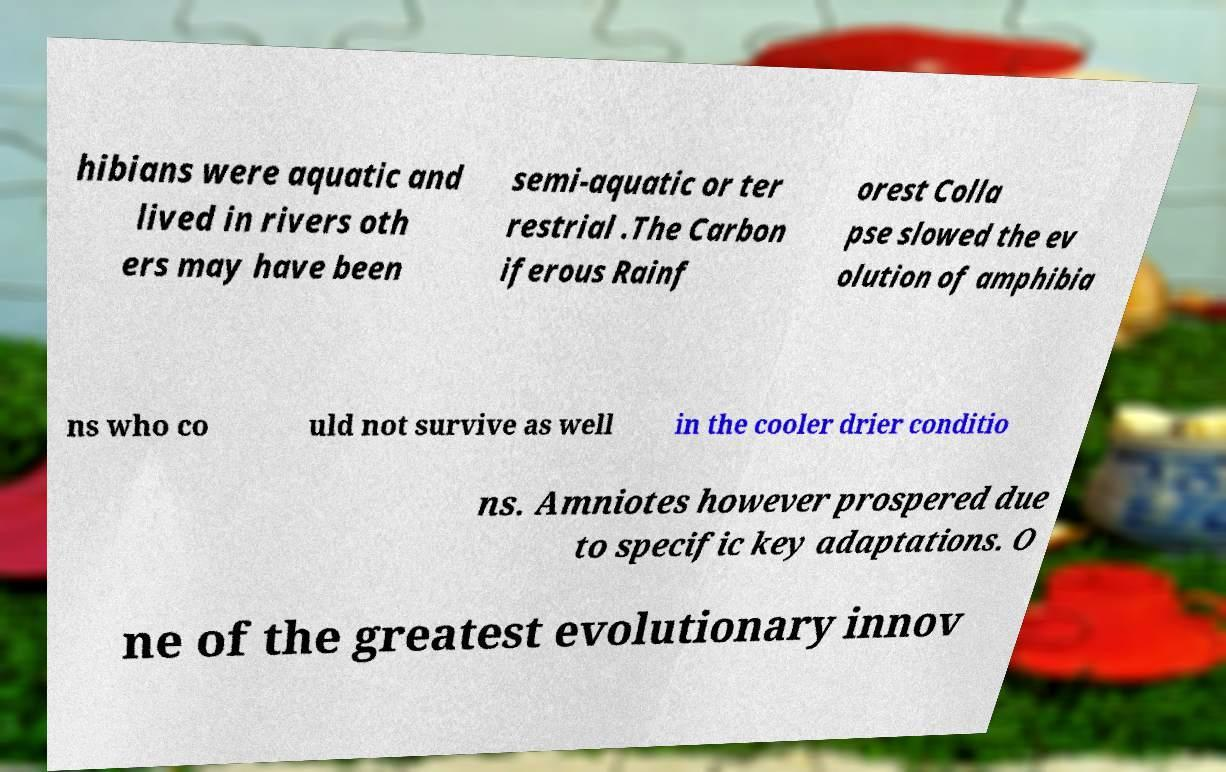Can you accurately transcribe the text from the provided image for me? hibians were aquatic and lived in rivers oth ers may have been semi-aquatic or ter restrial .The Carbon iferous Rainf orest Colla pse slowed the ev olution of amphibia ns who co uld not survive as well in the cooler drier conditio ns. Amniotes however prospered due to specific key adaptations. O ne of the greatest evolutionary innov 